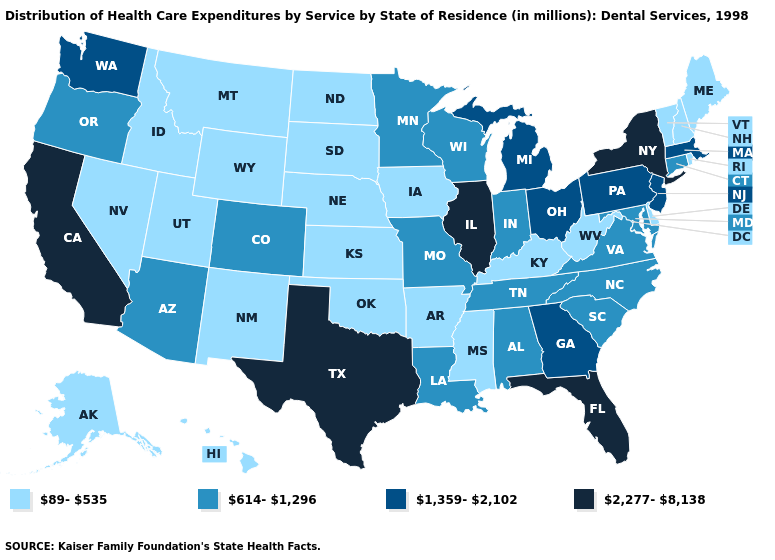Which states have the lowest value in the USA?
Give a very brief answer. Alaska, Arkansas, Delaware, Hawaii, Idaho, Iowa, Kansas, Kentucky, Maine, Mississippi, Montana, Nebraska, Nevada, New Hampshire, New Mexico, North Dakota, Oklahoma, Rhode Island, South Dakota, Utah, Vermont, West Virginia, Wyoming. Among the states that border Arkansas , which have the lowest value?
Short answer required. Mississippi, Oklahoma. Does the map have missing data?
Give a very brief answer. No. Among the states that border Washington , does Oregon have the lowest value?
Short answer required. No. Name the states that have a value in the range 89-535?
Keep it brief. Alaska, Arkansas, Delaware, Hawaii, Idaho, Iowa, Kansas, Kentucky, Maine, Mississippi, Montana, Nebraska, Nevada, New Hampshire, New Mexico, North Dakota, Oklahoma, Rhode Island, South Dakota, Utah, Vermont, West Virginia, Wyoming. Among the states that border North Dakota , which have the highest value?
Write a very short answer. Minnesota. Does Illinois have the highest value in the USA?
Give a very brief answer. Yes. Does the first symbol in the legend represent the smallest category?
Write a very short answer. Yes. Among the states that border Vermont , which have the highest value?
Concise answer only. New York. How many symbols are there in the legend?
Answer briefly. 4. How many symbols are there in the legend?
Write a very short answer. 4. Among the states that border Colorado , does Arizona have the highest value?
Short answer required. Yes. What is the value of Ohio?
Be succinct. 1,359-2,102. Among the states that border Iowa , does Minnesota have the highest value?
Write a very short answer. No. Name the states that have a value in the range 1,359-2,102?
Write a very short answer. Georgia, Massachusetts, Michigan, New Jersey, Ohio, Pennsylvania, Washington. 